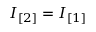Convert formula to latex. <formula><loc_0><loc_0><loc_500><loc_500>I _ { [ 2 ] } = I _ { [ 1 ] }</formula> 